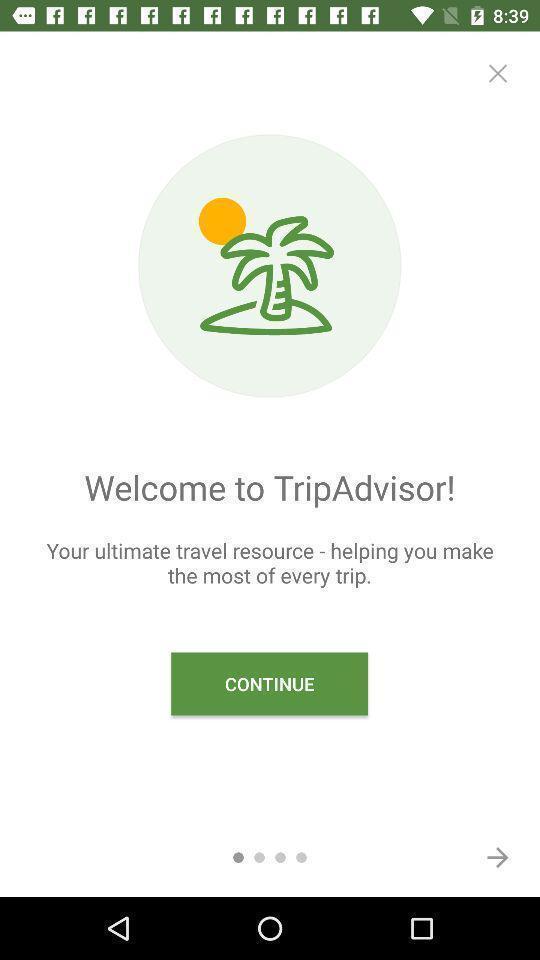Tell me about the visual elements in this screen capture. Welcome page. 